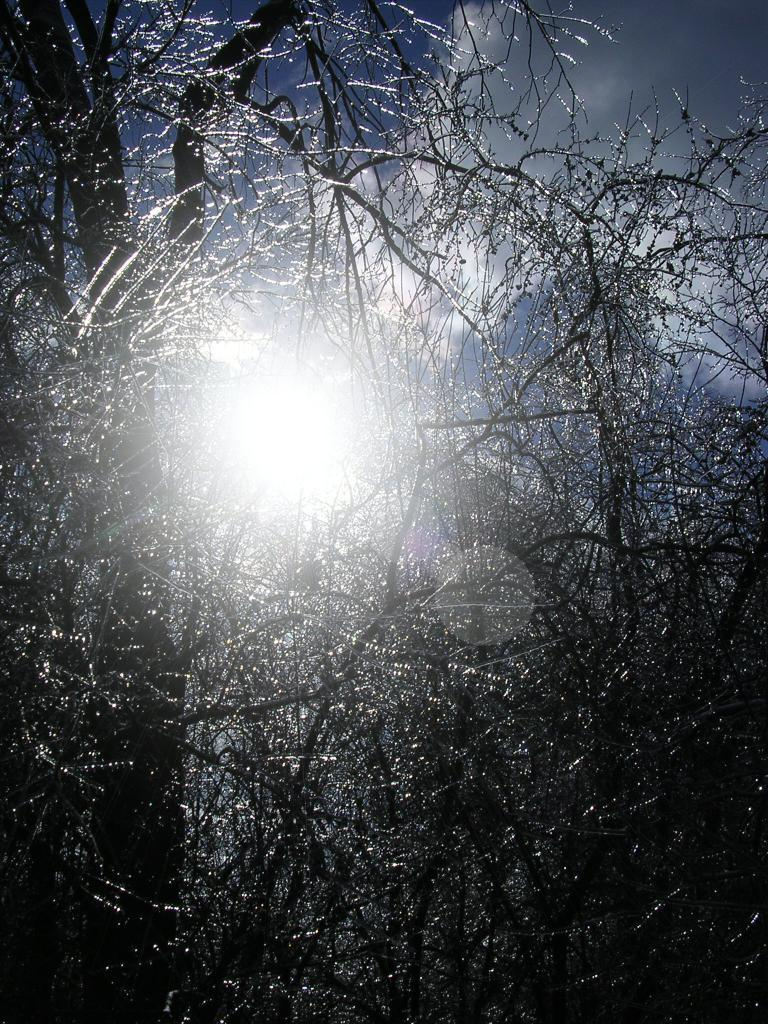What type of natural elements can be seen in the image? There are branches in the image. Can you describe the branches in more detail? Unfortunately, the provided facts do not offer more detail about the branches. What might be the source of the branches in the image? The branches could be from a tree or a bush, but the facts do not specify the source. How does the foot contribute to the harmony in the image? There is no foot present in the image, and therefore it cannot contribute to any harmony. 